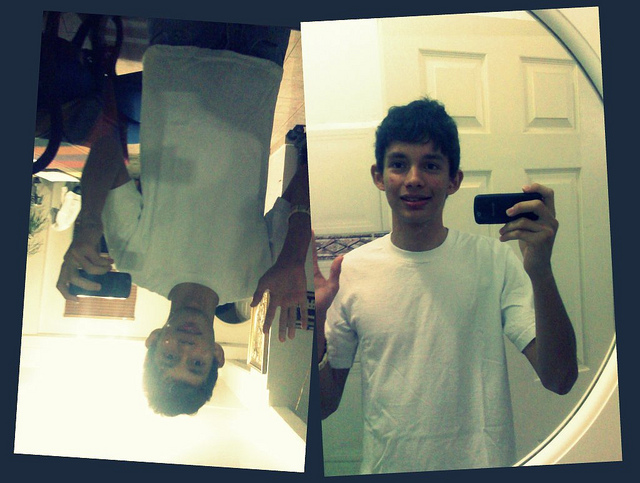Is there anything unusual about the orientation of the images? Yes, there is something unusual: one of the images is displayed upside-down, likely due to the reflection in the mirror. 